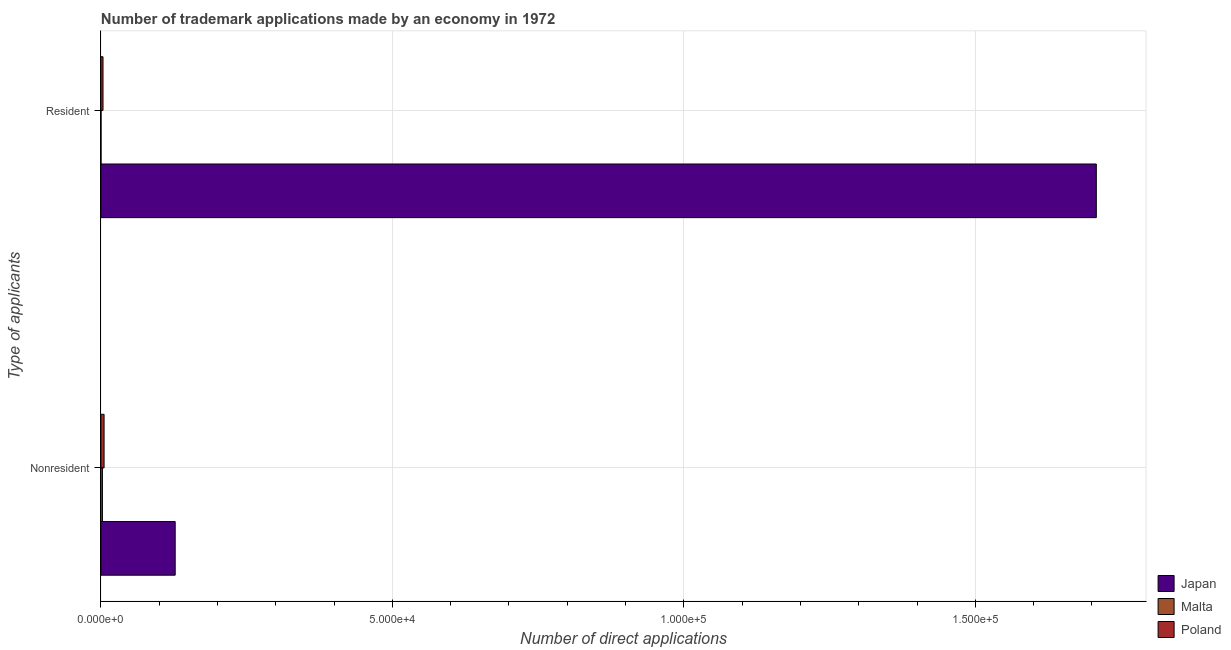How many different coloured bars are there?
Keep it short and to the point. 3. How many groups of bars are there?
Ensure brevity in your answer.  2. How many bars are there on the 2nd tick from the top?
Ensure brevity in your answer.  3. What is the label of the 1st group of bars from the top?
Provide a short and direct response. Resident. What is the number of trademark applications made by residents in Malta?
Make the answer very short. 32. Across all countries, what is the maximum number of trademark applications made by residents?
Your answer should be very brief. 1.71e+05. Across all countries, what is the minimum number of trademark applications made by residents?
Ensure brevity in your answer.  32. In which country was the number of trademark applications made by non residents maximum?
Your response must be concise. Japan. In which country was the number of trademark applications made by non residents minimum?
Provide a succinct answer. Malta. What is the total number of trademark applications made by non residents in the graph?
Your answer should be very brief. 1.36e+04. What is the difference between the number of trademark applications made by non residents in Japan and that in Poland?
Your answer should be very brief. 1.22e+04. What is the difference between the number of trademark applications made by residents in Poland and the number of trademark applications made by non residents in Japan?
Offer a very short reply. -1.24e+04. What is the average number of trademark applications made by residents per country?
Provide a short and direct response. 5.70e+04. What is the difference between the number of trademark applications made by non residents and number of trademark applications made by residents in Poland?
Offer a terse response. 181. In how many countries, is the number of trademark applications made by non residents greater than 20000 ?
Make the answer very short. 0. What is the ratio of the number of trademark applications made by non residents in Malta to that in Poland?
Ensure brevity in your answer.  0.49. Is the number of trademark applications made by residents in Poland less than that in Malta?
Offer a terse response. No. What does the 2nd bar from the top in Resident represents?
Your answer should be very brief. Malta. What does the 1st bar from the bottom in Nonresident represents?
Give a very brief answer. Japan. Are all the bars in the graph horizontal?
Give a very brief answer. Yes. How many countries are there in the graph?
Your answer should be very brief. 3. What is the difference between two consecutive major ticks on the X-axis?
Ensure brevity in your answer.  5.00e+04. Are the values on the major ticks of X-axis written in scientific E-notation?
Ensure brevity in your answer.  Yes. Does the graph contain any zero values?
Your answer should be compact. No. Where does the legend appear in the graph?
Your answer should be very brief. Bottom right. How many legend labels are there?
Provide a succinct answer. 3. What is the title of the graph?
Your answer should be compact. Number of trademark applications made by an economy in 1972. Does "Gabon" appear as one of the legend labels in the graph?
Your answer should be very brief. No. What is the label or title of the X-axis?
Your answer should be very brief. Number of direct applications. What is the label or title of the Y-axis?
Keep it short and to the point. Type of applicants. What is the Number of direct applications of Japan in Nonresident?
Provide a succinct answer. 1.28e+04. What is the Number of direct applications of Malta in Nonresident?
Offer a terse response. 272. What is the Number of direct applications in Poland in Nonresident?
Provide a short and direct response. 554. What is the Number of direct applications of Japan in Resident?
Make the answer very short. 1.71e+05. What is the Number of direct applications of Poland in Resident?
Offer a very short reply. 373. Across all Type of applicants, what is the maximum Number of direct applications of Japan?
Your response must be concise. 1.71e+05. Across all Type of applicants, what is the maximum Number of direct applications of Malta?
Make the answer very short. 272. Across all Type of applicants, what is the maximum Number of direct applications in Poland?
Offer a very short reply. 554. Across all Type of applicants, what is the minimum Number of direct applications of Japan?
Your answer should be compact. 1.28e+04. Across all Type of applicants, what is the minimum Number of direct applications in Poland?
Provide a succinct answer. 373. What is the total Number of direct applications in Japan in the graph?
Offer a terse response. 1.83e+05. What is the total Number of direct applications of Malta in the graph?
Give a very brief answer. 304. What is the total Number of direct applications of Poland in the graph?
Your response must be concise. 927. What is the difference between the Number of direct applications in Japan in Nonresident and that in Resident?
Your response must be concise. -1.58e+05. What is the difference between the Number of direct applications of Malta in Nonresident and that in Resident?
Provide a short and direct response. 240. What is the difference between the Number of direct applications of Poland in Nonresident and that in Resident?
Give a very brief answer. 181. What is the difference between the Number of direct applications of Japan in Nonresident and the Number of direct applications of Malta in Resident?
Offer a very short reply. 1.27e+04. What is the difference between the Number of direct applications in Japan in Nonresident and the Number of direct applications in Poland in Resident?
Offer a terse response. 1.24e+04. What is the difference between the Number of direct applications in Malta in Nonresident and the Number of direct applications in Poland in Resident?
Give a very brief answer. -101. What is the average Number of direct applications of Japan per Type of applicants?
Your answer should be compact. 9.17e+04. What is the average Number of direct applications of Malta per Type of applicants?
Your answer should be compact. 152. What is the average Number of direct applications of Poland per Type of applicants?
Make the answer very short. 463.5. What is the difference between the Number of direct applications in Japan and Number of direct applications in Malta in Nonresident?
Your answer should be very brief. 1.25e+04. What is the difference between the Number of direct applications of Japan and Number of direct applications of Poland in Nonresident?
Your response must be concise. 1.22e+04. What is the difference between the Number of direct applications in Malta and Number of direct applications in Poland in Nonresident?
Offer a very short reply. -282. What is the difference between the Number of direct applications of Japan and Number of direct applications of Malta in Resident?
Provide a short and direct response. 1.71e+05. What is the difference between the Number of direct applications in Japan and Number of direct applications in Poland in Resident?
Your response must be concise. 1.70e+05. What is the difference between the Number of direct applications of Malta and Number of direct applications of Poland in Resident?
Provide a succinct answer. -341. What is the ratio of the Number of direct applications in Japan in Nonresident to that in Resident?
Make the answer very short. 0.07. What is the ratio of the Number of direct applications of Poland in Nonresident to that in Resident?
Keep it short and to the point. 1.49. What is the difference between the highest and the second highest Number of direct applications of Japan?
Give a very brief answer. 1.58e+05. What is the difference between the highest and the second highest Number of direct applications of Malta?
Your answer should be compact. 240. What is the difference between the highest and the second highest Number of direct applications in Poland?
Keep it short and to the point. 181. What is the difference between the highest and the lowest Number of direct applications of Japan?
Offer a terse response. 1.58e+05. What is the difference between the highest and the lowest Number of direct applications in Malta?
Provide a succinct answer. 240. What is the difference between the highest and the lowest Number of direct applications in Poland?
Your answer should be compact. 181. 